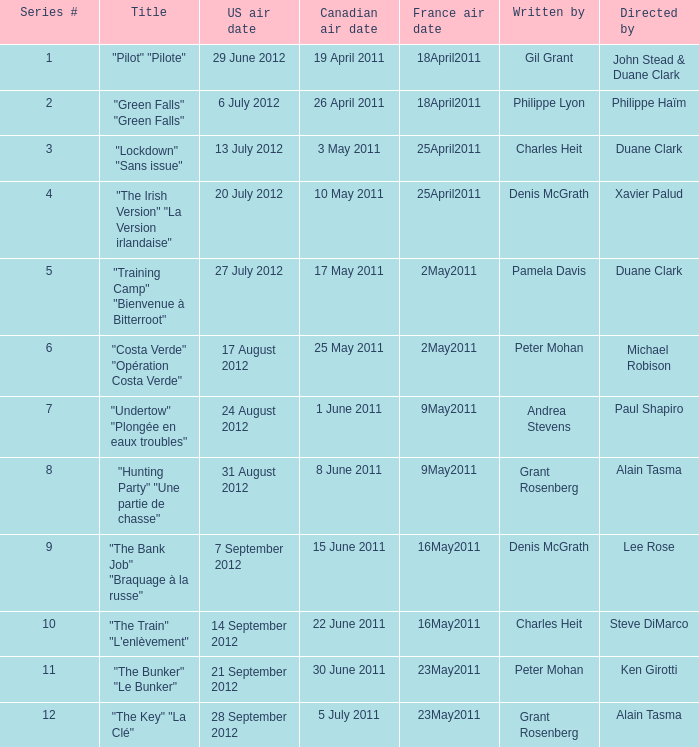What is the US air date when the director is ken girotti? 21 September 2012. 